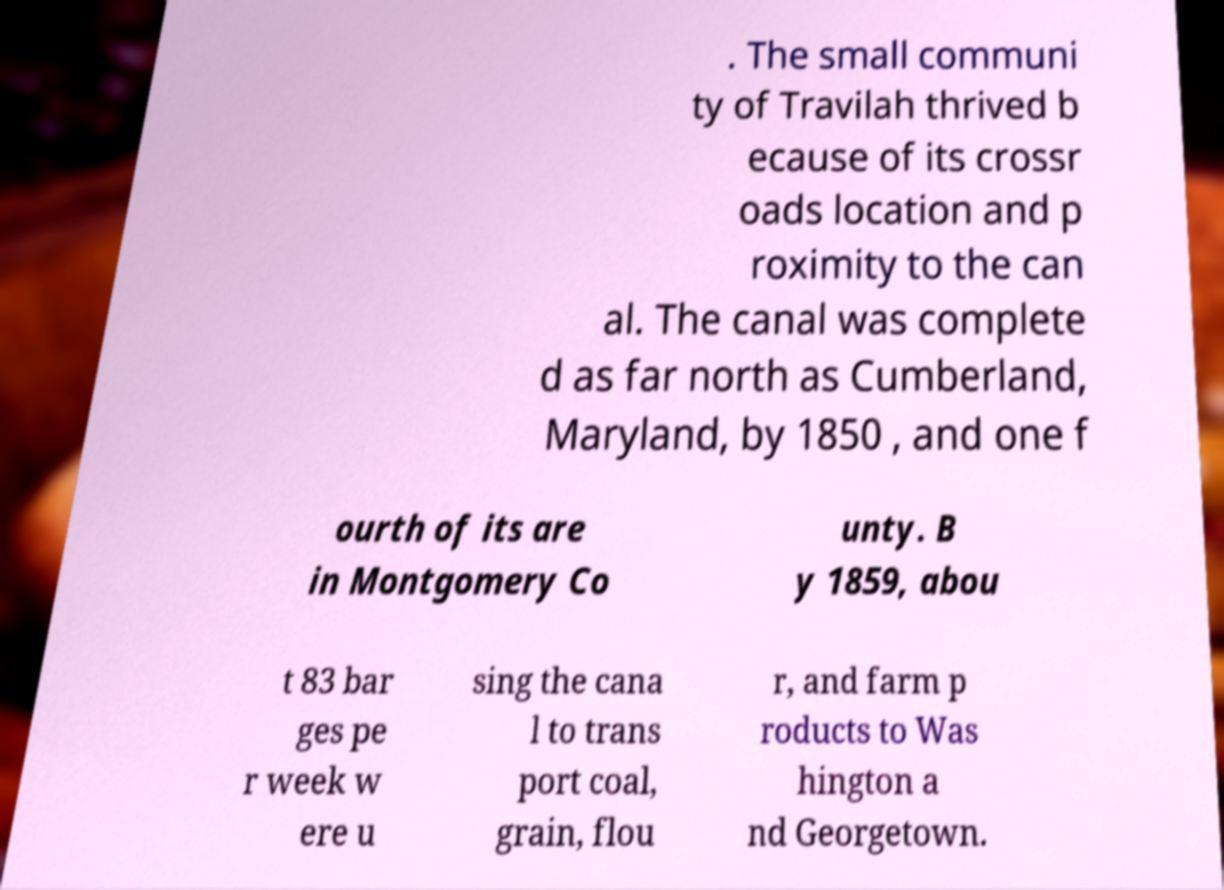For documentation purposes, I need the text within this image transcribed. Could you provide that? . The small communi ty of Travilah thrived b ecause of its crossr oads location and p roximity to the can al. The canal was complete d as far north as Cumberland, Maryland, by 1850 , and one f ourth of its are in Montgomery Co unty. B y 1859, abou t 83 bar ges pe r week w ere u sing the cana l to trans port coal, grain, flou r, and farm p roducts to Was hington a nd Georgetown. 